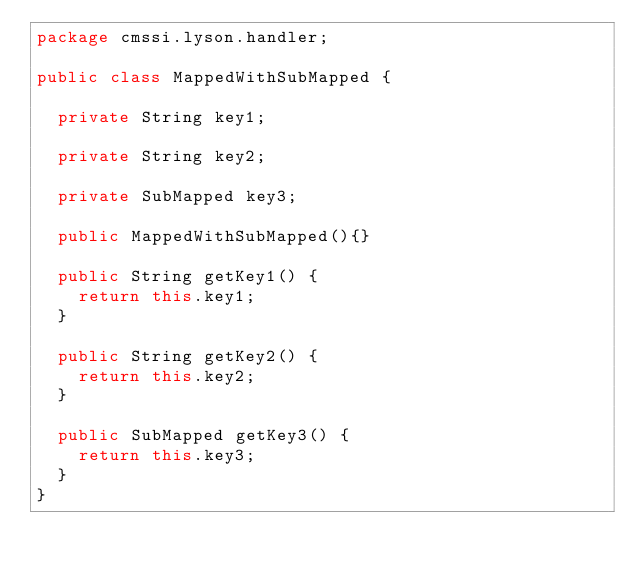Convert code to text. <code><loc_0><loc_0><loc_500><loc_500><_Java_>package cmssi.lyson.handler;

public class MappedWithSubMapped {

	private String key1;
	
	private String key2;
			
	private SubMapped key3;

	public MappedWithSubMapped(){}
	
	public String getKey1() {
		return this.key1;
	}
	
	public String getKey2() {
		return this.key2;
	}
	
	public SubMapped getKey3() {
		return this.key3;
	}
}
</code> 